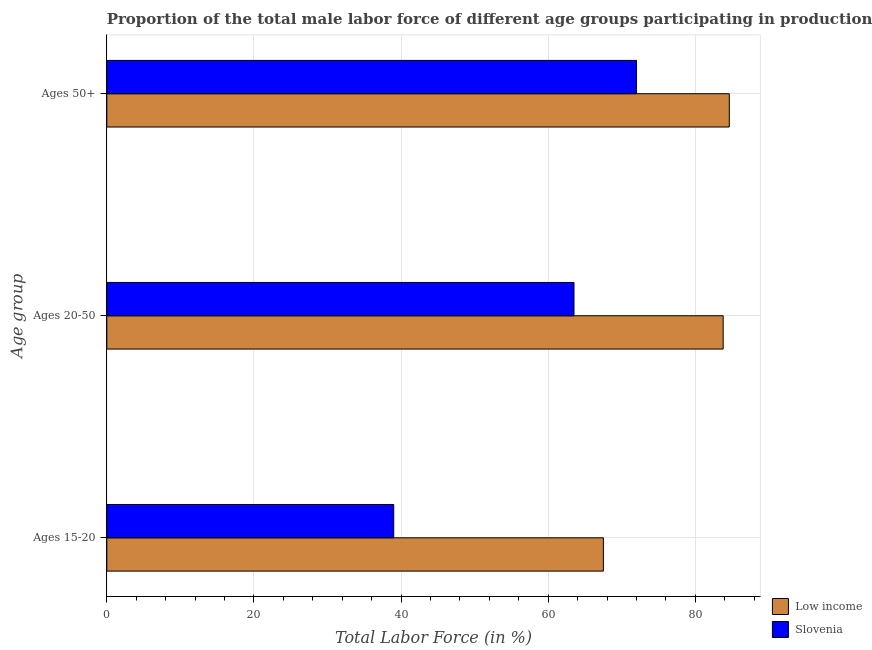How many groups of bars are there?
Your response must be concise. 3. What is the label of the 2nd group of bars from the top?
Offer a very short reply. Ages 20-50. What is the percentage of male labor force above age 50 in Low income?
Offer a very short reply. 84.61. Across all countries, what is the maximum percentage of male labor force within the age group 20-50?
Your response must be concise. 83.78. In which country was the percentage of male labor force within the age group 20-50 minimum?
Offer a very short reply. Slovenia. What is the total percentage of male labor force within the age group 20-50 in the graph?
Keep it short and to the point. 147.28. What is the difference between the percentage of male labor force within the age group 15-20 in Low income and that in Slovenia?
Your answer should be very brief. 28.5. What is the difference between the percentage of male labor force within the age group 20-50 in Slovenia and the percentage of male labor force within the age group 15-20 in Low income?
Provide a short and direct response. -4. What is the average percentage of male labor force within the age group 20-50 per country?
Offer a very short reply. 73.64. What is the difference between the percentage of male labor force within the age group 15-20 and percentage of male labor force within the age group 20-50 in Slovenia?
Your answer should be very brief. -24.5. In how many countries, is the percentage of male labor force within the age group 15-20 greater than 56 %?
Ensure brevity in your answer.  1. What is the ratio of the percentage of male labor force within the age group 20-50 in Low income to that in Slovenia?
Make the answer very short. 1.32. What is the difference between the highest and the second highest percentage of male labor force within the age group 15-20?
Your response must be concise. 28.5. What is the difference between the highest and the lowest percentage of male labor force within the age group 15-20?
Keep it short and to the point. 28.5. In how many countries, is the percentage of male labor force within the age group 20-50 greater than the average percentage of male labor force within the age group 20-50 taken over all countries?
Your response must be concise. 1. Is the sum of the percentage of male labor force within the age group 20-50 in Low income and Slovenia greater than the maximum percentage of male labor force within the age group 15-20 across all countries?
Your answer should be compact. Yes. What does the 1st bar from the top in Ages 15-20 represents?
Offer a very short reply. Slovenia. What does the 2nd bar from the bottom in Ages 20-50 represents?
Your answer should be compact. Slovenia. How many legend labels are there?
Make the answer very short. 2. How are the legend labels stacked?
Provide a succinct answer. Vertical. What is the title of the graph?
Provide a short and direct response. Proportion of the total male labor force of different age groups participating in production in 2003. Does "Rwanda" appear as one of the legend labels in the graph?
Your answer should be compact. No. What is the label or title of the X-axis?
Provide a short and direct response. Total Labor Force (in %). What is the label or title of the Y-axis?
Your response must be concise. Age group. What is the Total Labor Force (in %) in Low income in Ages 15-20?
Your answer should be compact. 67.5. What is the Total Labor Force (in %) in Slovenia in Ages 15-20?
Keep it short and to the point. 39. What is the Total Labor Force (in %) in Low income in Ages 20-50?
Make the answer very short. 83.78. What is the Total Labor Force (in %) in Slovenia in Ages 20-50?
Make the answer very short. 63.5. What is the Total Labor Force (in %) of Low income in Ages 50+?
Ensure brevity in your answer.  84.61. What is the Total Labor Force (in %) of Slovenia in Ages 50+?
Your response must be concise. 72. Across all Age group, what is the maximum Total Labor Force (in %) in Low income?
Offer a terse response. 84.61. Across all Age group, what is the maximum Total Labor Force (in %) in Slovenia?
Offer a very short reply. 72. Across all Age group, what is the minimum Total Labor Force (in %) of Low income?
Ensure brevity in your answer.  67.5. Across all Age group, what is the minimum Total Labor Force (in %) in Slovenia?
Your response must be concise. 39. What is the total Total Labor Force (in %) of Low income in the graph?
Offer a very short reply. 235.88. What is the total Total Labor Force (in %) in Slovenia in the graph?
Ensure brevity in your answer.  174.5. What is the difference between the Total Labor Force (in %) in Low income in Ages 15-20 and that in Ages 20-50?
Offer a terse response. -16.28. What is the difference between the Total Labor Force (in %) of Slovenia in Ages 15-20 and that in Ages 20-50?
Your answer should be compact. -24.5. What is the difference between the Total Labor Force (in %) of Low income in Ages 15-20 and that in Ages 50+?
Provide a short and direct response. -17.11. What is the difference between the Total Labor Force (in %) of Slovenia in Ages 15-20 and that in Ages 50+?
Give a very brief answer. -33. What is the difference between the Total Labor Force (in %) of Low income in Ages 20-50 and that in Ages 50+?
Your answer should be compact. -0.83. What is the difference between the Total Labor Force (in %) of Slovenia in Ages 20-50 and that in Ages 50+?
Give a very brief answer. -8.5. What is the difference between the Total Labor Force (in %) in Low income in Ages 15-20 and the Total Labor Force (in %) in Slovenia in Ages 20-50?
Your answer should be very brief. 4. What is the difference between the Total Labor Force (in %) of Low income in Ages 15-20 and the Total Labor Force (in %) of Slovenia in Ages 50+?
Ensure brevity in your answer.  -4.5. What is the difference between the Total Labor Force (in %) in Low income in Ages 20-50 and the Total Labor Force (in %) in Slovenia in Ages 50+?
Provide a succinct answer. 11.78. What is the average Total Labor Force (in %) of Low income per Age group?
Keep it short and to the point. 78.63. What is the average Total Labor Force (in %) of Slovenia per Age group?
Offer a terse response. 58.17. What is the difference between the Total Labor Force (in %) in Low income and Total Labor Force (in %) in Slovenia in Ages 15-20?
Offer a terse response. 28.5. What is the difference between the Total Labor Force (in %) of Low income and Total Labor Force (in %) of Slovenia in Ages 20-50?
Ensure brevity in your answer.  20.28. What is the difference between the Total Labor Force (in %) of Low income and Total Labor Force (in %) of Slovenia in Ages 50+?
Offer a terse response. 12.61. What is the ratio of the Total Labor Force (in %) of Low income in Ages 15-20 to that in Ages 20-50?
Make the answer very short. 0.81. What is the ratio of the Total Labor Force (in %) of Slovenia in Ages 15-20 to that in Ages 20-50?
Ensure brevity in your answer.  0.61. What is the ratio of the Total Labor Force (in %) of Low income in Ages 15-20 to that in Ages 50+?
Give a very brief answer. 0.8. What is the ratio of the Total Labor Force (in %) in Slovenia in Ages 15-20 to that in Ages 50+?
Keep it short and to the point. 0.54. What is the ratio of the Total Labor Force (in %) of Low income in Ages 20-50 to that in Ages 50+?
Make the answer very short. 0.99. What is the ratio of the Total Labor Force (in %) in Slovenia in Ages 20-50 to that in Ages 50+?
Keep it short and to the point. 0.88. What is the difference between the highest and the second highest Total Labor Force (in %) in Low income?
Your answer should be very brief. 0.83. What is the difference between the highest and the lowest Total Labor Force (in %) in Low income?
Keep it short and to the point. 17.11. What is the difference between the highest and the lowest Total Labor Force (in %) in Slovenia?
Offer a very short reply. 33. 